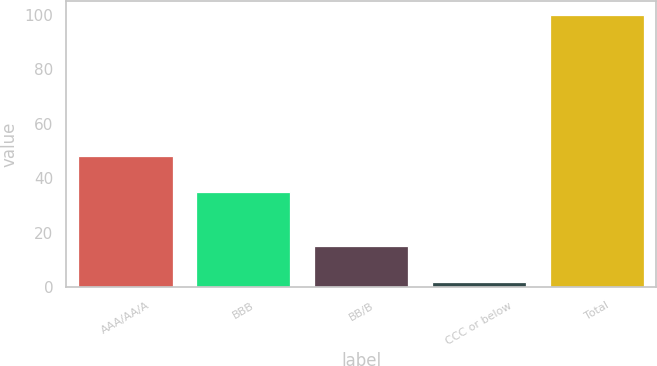Convert chart to OTSL. <chart><loc_0><loc_0><loc_500><loc_500><bar_chart><fcel>AAA/AA/A<fcel>BBB<fcel>BB/B<fcel>CCC or below<fcel>Total<nl><fcel>48<fcel>35<fcel>15<fcel>2<fcel>100<nl></chart> 